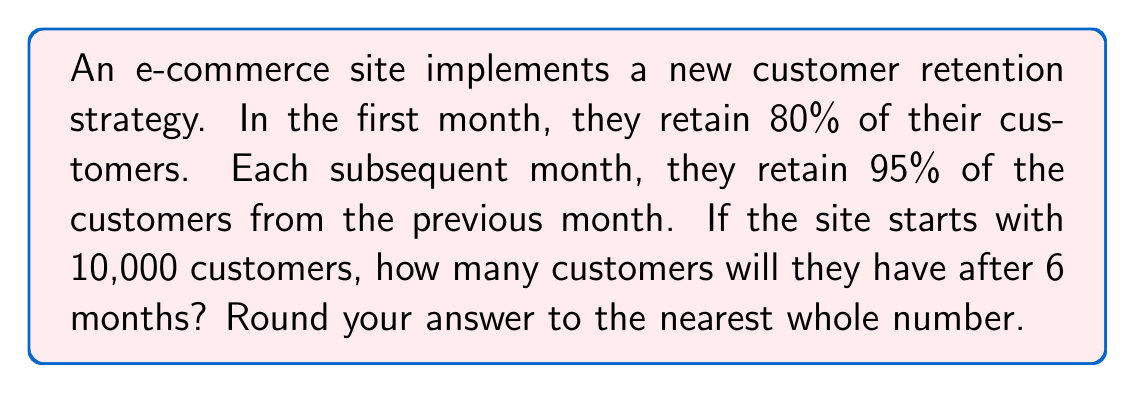Provide a solution to this math problem. Let's approach this step-by-step using a geometric sequence:

1) Initial number of customers: $a_1 = 10,000 \times 0.80 = 8,000$

2) Common ratio: $r = 0.95$

3) We need to find the 6th term of this geometric sequence.

4) The formula for the nth term of a geometric sequence is:
   $a_n = a_1 \times r^{n-1}$

5) Substituting our values:
   $a_6 = 8,000 \times 0.95^{6-1}$
   $a_6 = 8,000 \times 0.95^5$

6) Calculate:
   $a_6 = 8,000 \times 0.7738416975$
   $a_6 = 6,190.73358$

7) Rounding to the nearest whole number:
   $a_6 \approx 6,191$

This means after 6 months, the e-commerce site will have approximately 6,191 customers.
Answer: 6,191 customers 